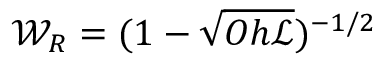Convert formula to latex. <formula><loc_0><loc_0><loc_500><loc_500>{ \mathcal { W } } _ { R } = { ( 1 - \sqrt { O h { \ m a t h s c r { L } } } ) ^ { - 1 / 2 } }</formula> 